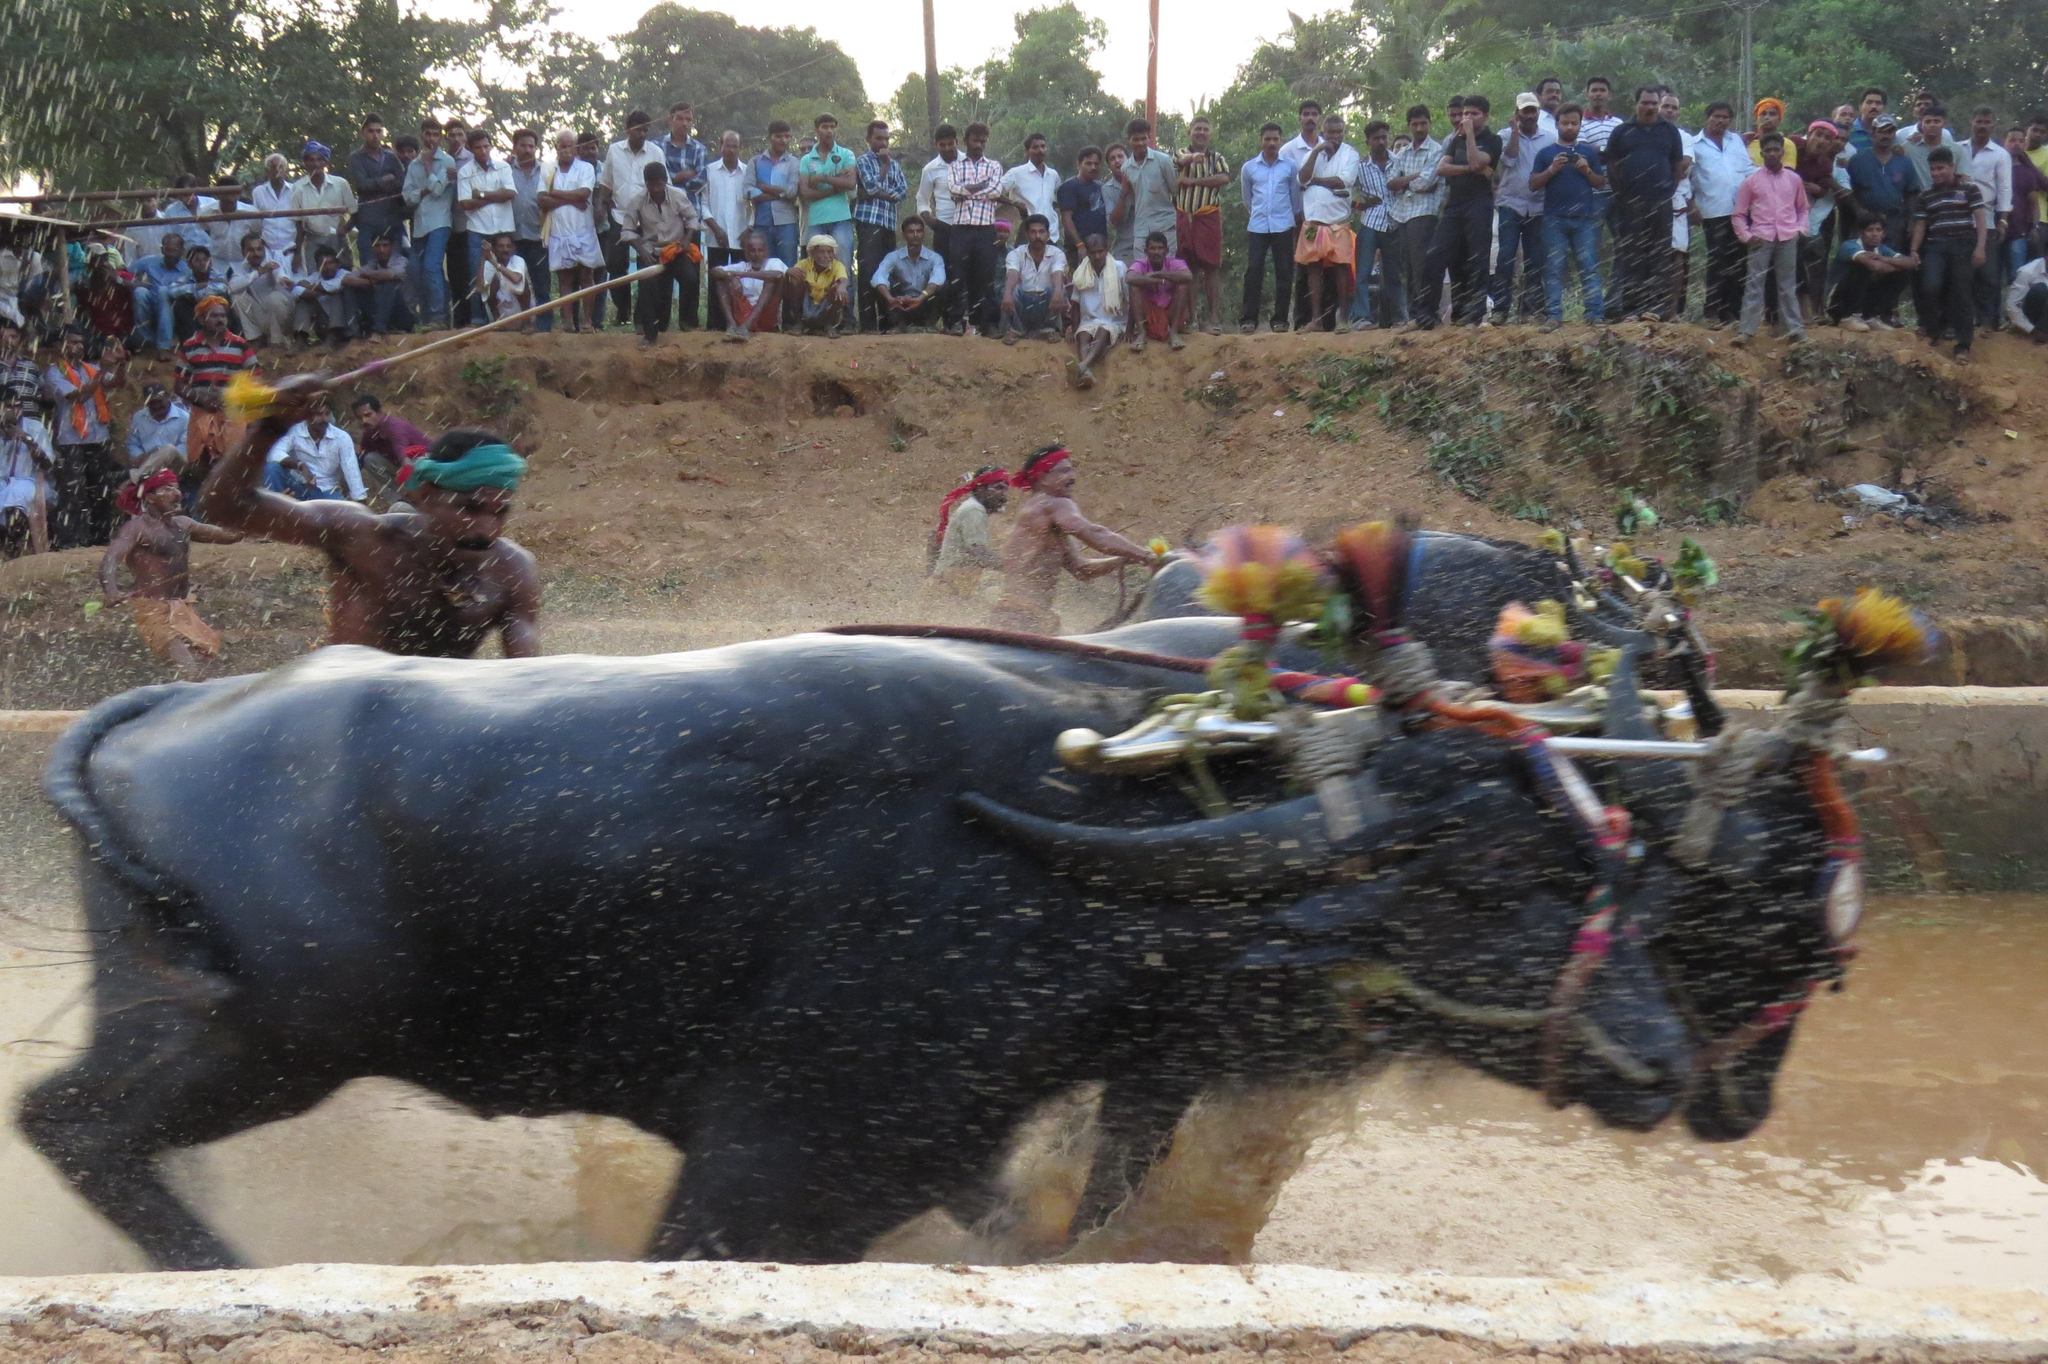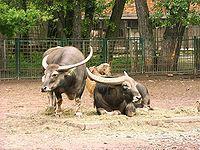The first image is the image on the left, the second image is the image on the right. Examine the images to the left and right. Is the description "In the left image, a man in a colored head wrap is standing behind two dark oxen and holding out a stick." accurate? Answer yes or no. Yes. The first image is the image on the left, the second image is the image on the right. Assess this claim about the two images: "A man is hitting an animal with a stick.". Correct or not? Answer yes or no. Yes. 